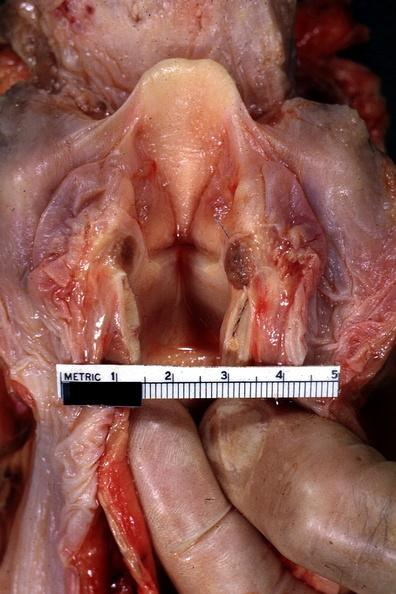what shows quite well?
Answer the question using a single word or phrase. Opened larynx 